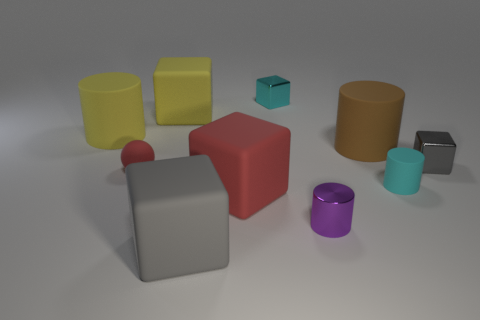Subtract 1 blocks. How many blocks are left? 4 Subtract all cylinders. How many objects are left? 6 Subtract all brown matte objects. Subtract all tiny cyan metallic things. How many objects are left? 8 Add 7 yellow rubber objects. How many yellow rubber objects are left? 9 Add 8 large gray rubber things. How many large gray rubber things exist? 9 Subtract 1 yellow cylinders. How many objects are left? 9 